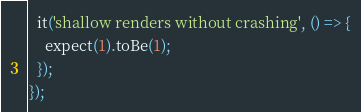<code> <loc_0><loc_0><loc_500><loc_500><_JavaScript_>
  it('shallow renders without crashing', () => {
    expect(1).toBe(1);
  });
});
</code> 